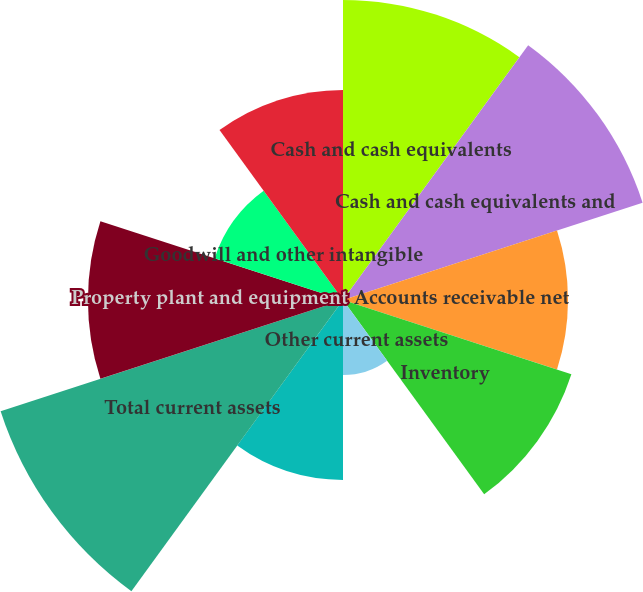Convert chart. <chart><loc_0><loc_0><loc_500><loc_500><pie_chart><fcel>Cash and cash equivalents<fcel>Cash and cash equivalents and<fcel>Accounts receivable net<fcel>Inventory<fcel>Other current assets<fcel>Current assets of discontinued<fcel>Total current assets<fcel>Property plant and equipment<fcel>Goodwill and other intangible<fcel>Other assets<nl><fcel>13.07%<fcel>13.72%<fcel>9.8%<fcel>10.46%<fcel>3.27%<fcel>7.84%<fcel>15.68%<fcel>11.11%<fcel>5.88%<fcel>9.15%<nl></chart> 